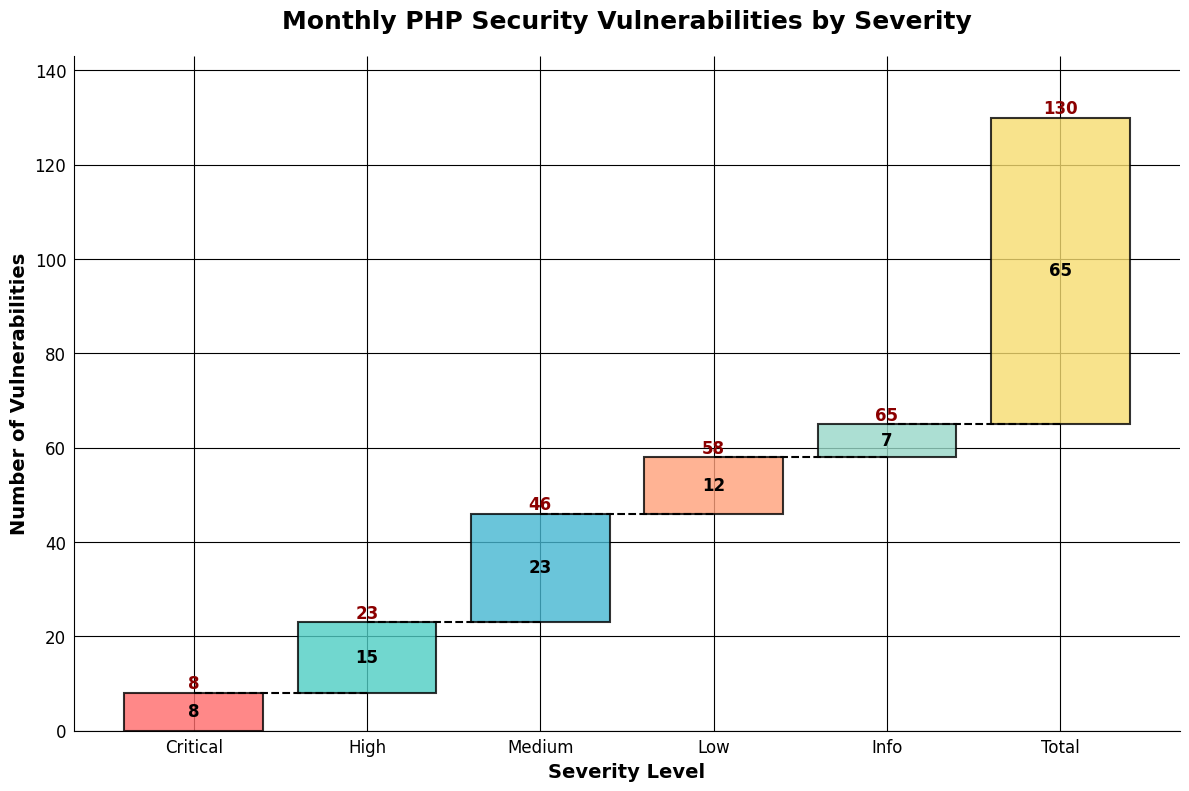What is the title of the plot? The title of the plot is displayed at the top center of the figure. It reads "Monthly PHP Security Vulnerabilities by Severity".
Answer: Monthly PHP Security Vulnerabilities by Severity What are the severity levels displayed on the x-axis? The x-axis of the figure has labels representing different severity levels, which are "Critical", "High", "Medium", "Low", and "Info".
Answer: Critical, High, Medium, Low, Info How many vulnerabilities were discovered at the "High" severity level? Referring to the bar labeled "High" on the plot, we can see that 15 vulnerabilities were discovered at the high severity level.
Answer: 15 What is the cumulative number of vulnerabilities up to the "Medium" severity level? The cumulative number is calculated as the sum of vulnerabilities from "Critical" through "Medium". From the plot: 8 (Critical) + 15 (High) + 23 (Medium) = 46.
Answer: 46 Which severity level had the fewest vulnerabilities discovered, and how many were there? By examining the heights of the bars in the chart, we see that the "Info" severity level has the fewest vulnerabilities reported, which is 7 vulnerabilities.
Answer: Info, 7 What is the total number of vulnerabilities displayed in the figure? The total number of vulnerabilities is represented by the "Total" bar, which sums to 65 vulnerabilities.
Answer: 65 How many more "Medium" severity vulnerabilities are there compared to "Low"? The values for "Medium" and "Low" are provided in the chart as 23 and 12, respectively. The difference is calculated as 23 - 12 = 11.
Answer: 11 What is the cumulative number of vulnerabilities up to "Low" severity level? Sum the vulnerabilities from "Critical" to "Low". From the plot: 8 (Critical) + 15 (High) + 23 (Medium) + 12 (Low) = 58.
Answer: 58 What color represents the "Critical" severity level in the chart? The "Critical" bar is colored in red, as indicated by the visual attributes of the chart.
Answer: Red How does the plot indicate the transition between cumulative values across severity levels? The plot uses dashed lines connecting the top of each cumulative bar to the next, showing the transition between cumulative values.
Answer: Dashed lines 